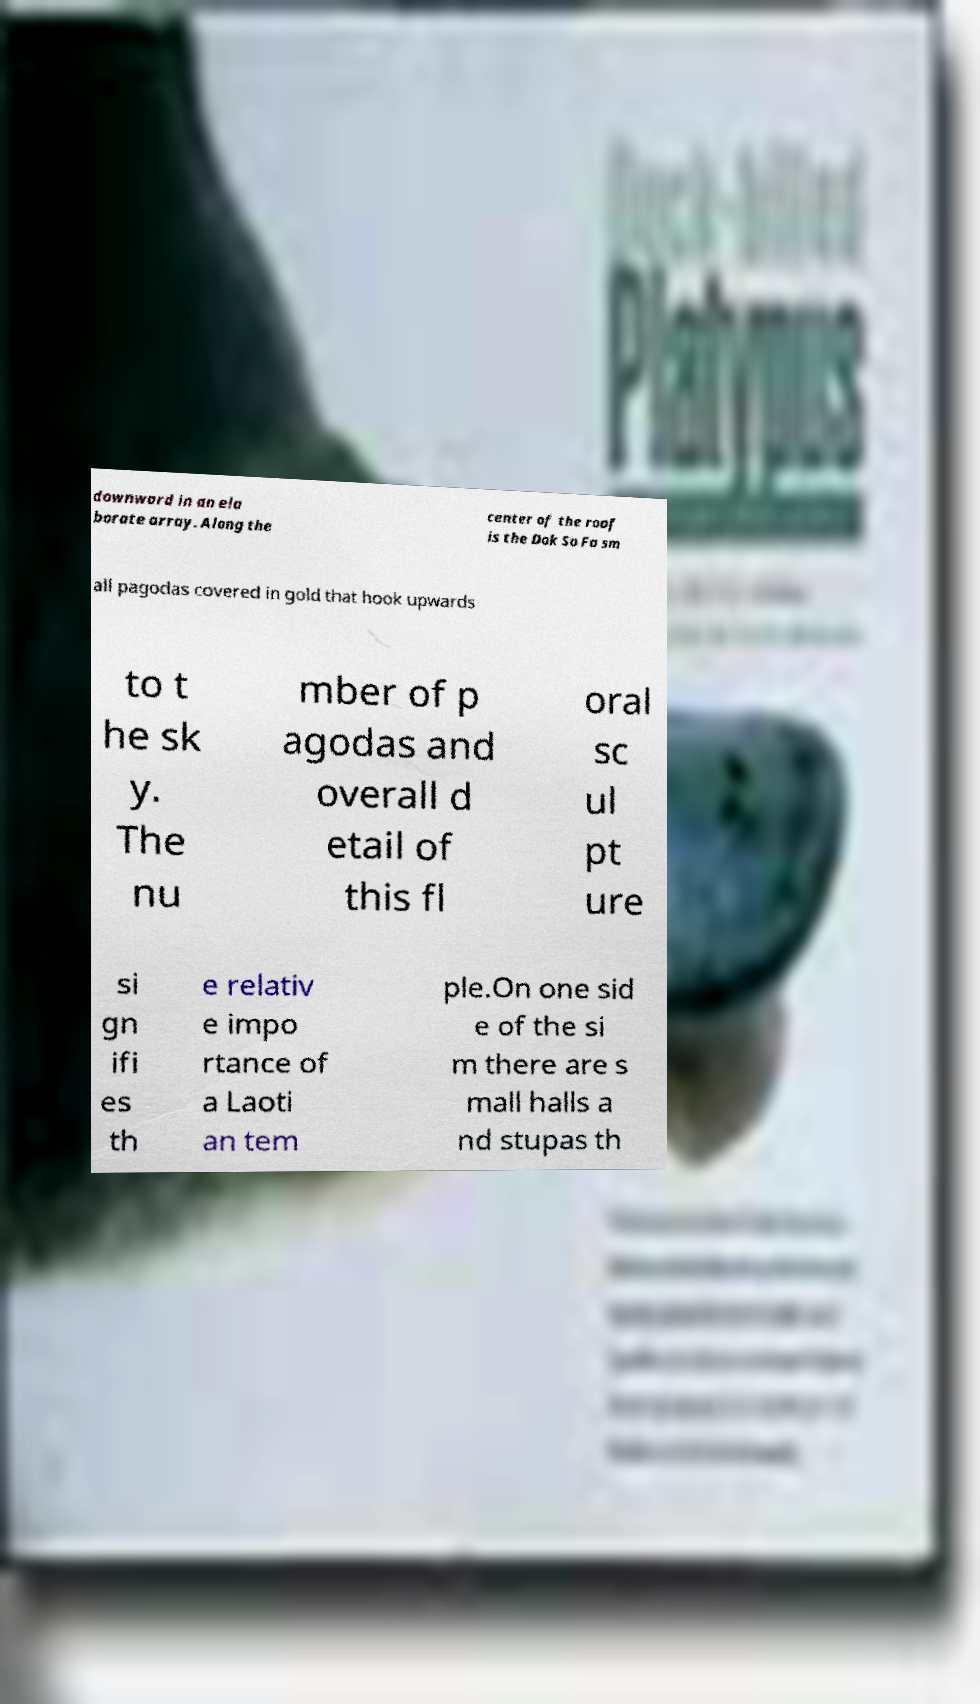Please identify and transcribe the text found in this image. downward in an ela borate array. Along the center of the roof is the Dok So Fa sm all pagodas covered in gold that hook upwards to t he sk y. The nu mber of p agodas and overall d etail of this fl oral sc ul pt ure si gn ifi es th e relativ e impo rtance of a Laoti an tem ple.On one sid e of the si m there are s mall halls a nd stupas th 